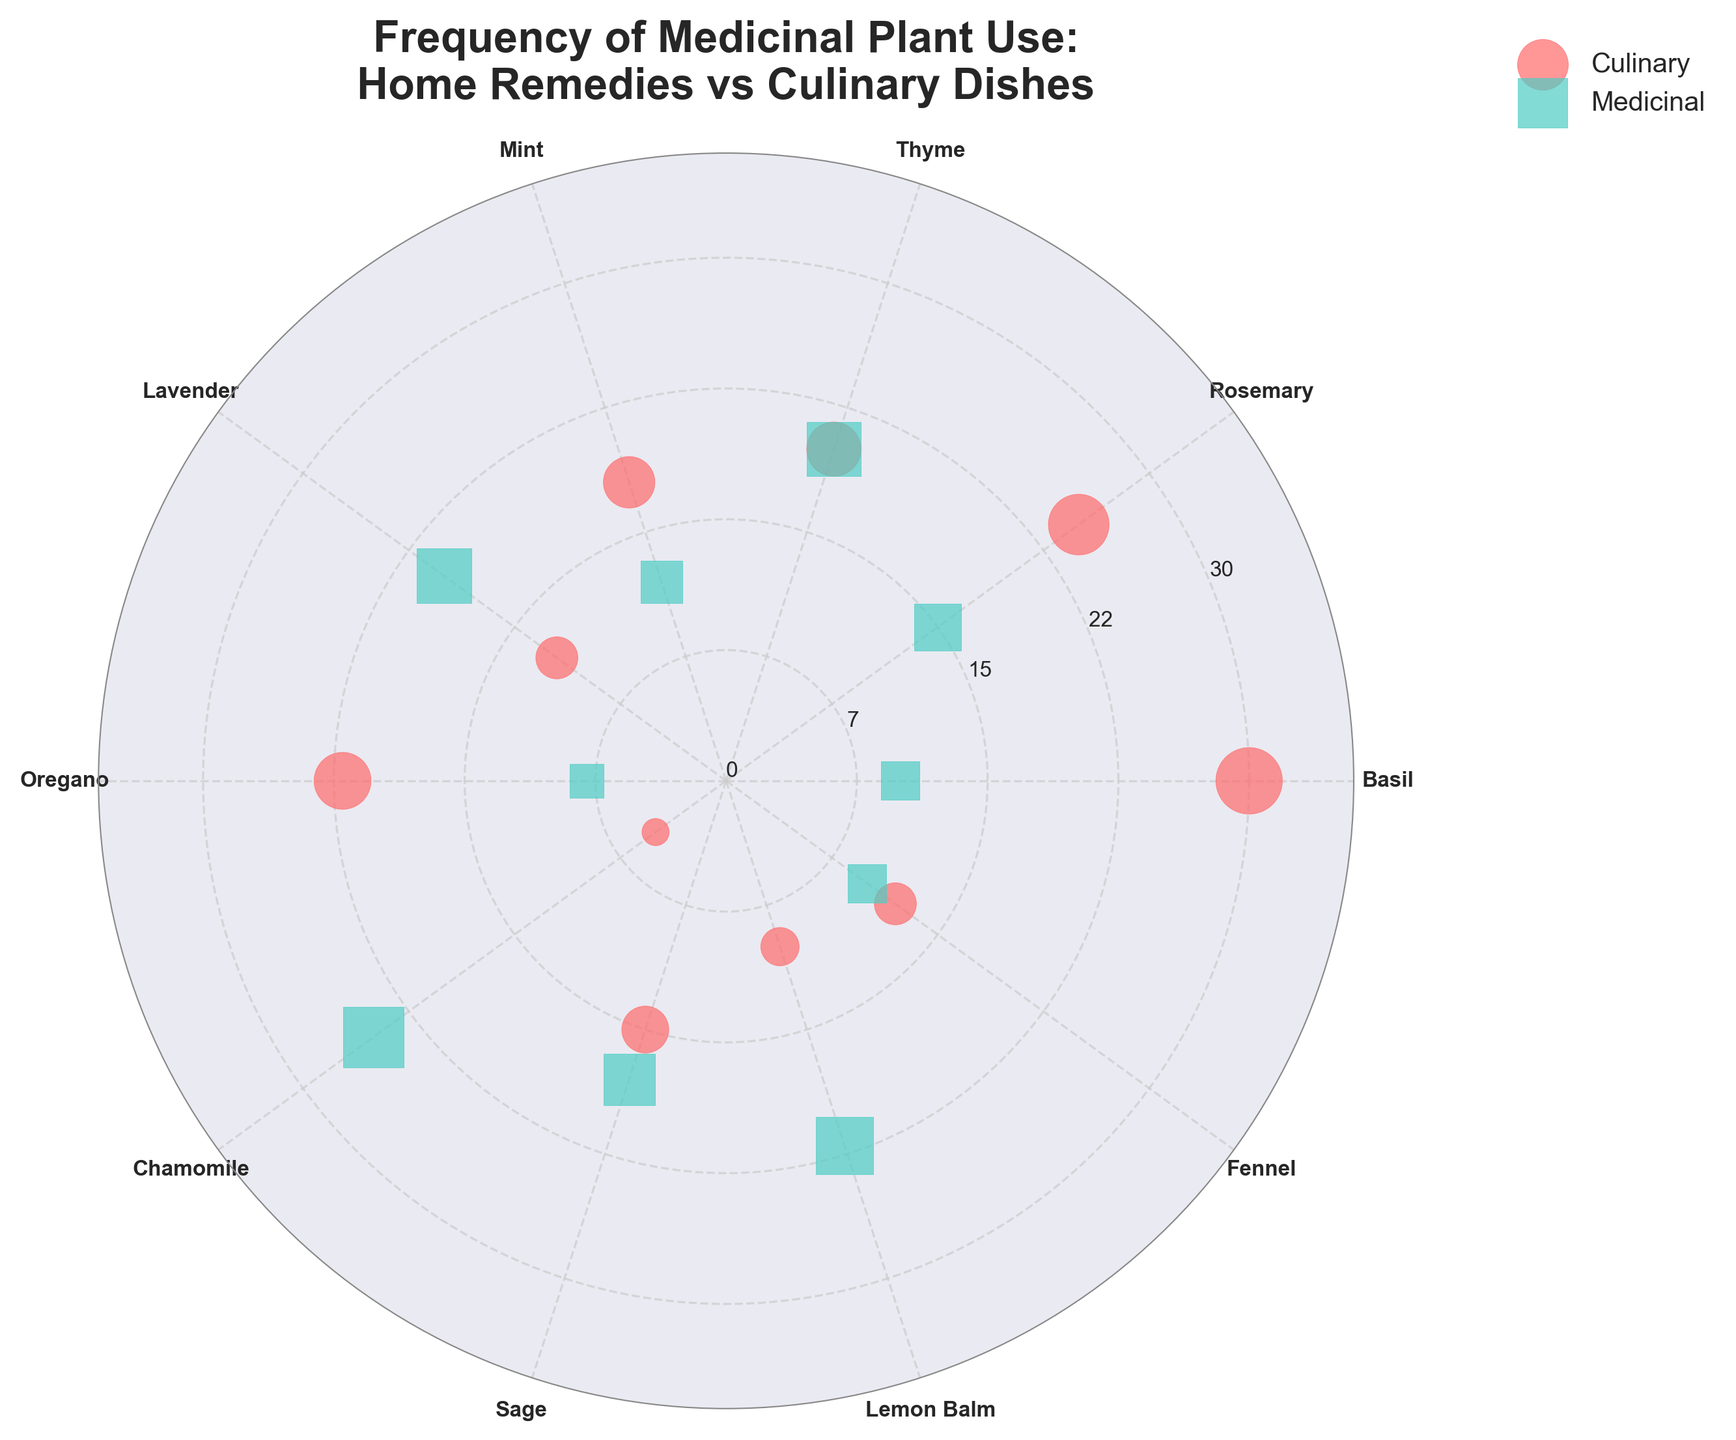What's the title of the chart? The title is prominently displayed at the top of the chart.
Answer: Frequency of Medicinal Plant Use: Home Remedies vs Culinary Dishes Which color represents the culinary category? By referring to the legend on the chart, the color associated with "Culinary" is clear.
Answer: Red How many medicinal plants have higher frequencies in home remedies than in culinary dishes? By comparing the frequencies of the "Medicinal" and "Culinary" categories for each plant, we can count the plants where the medicinal frequency is higher.
Answer: 5 For which plant is the frequency equal in both medicinal and culinary categories? By observing the scatter points, find the plant where the points are at the same radial distance for both categories.
Answer: Thyme Which plant has the highest frequency in culinary dishes? By looking at the culinary category points, identify the one farthest from the center.
Answer: Basil What's the range of frequencies depicted on the radial axis? Observing the radial axis ticks, we can determine the minimum and maximum frequency values.
Answer: 0 to 30 Is there a plant used more frequently in home remedies compared to culinary dishes by more than 10 units? Using the scatter points, check if any medicinal frequency exceeds by 10 units over the culinary frequency for the same plant.
Answer: Yes, Chamomile How many plants are plotted in total? Each unique label around the plot corresponds to a plant. Counting these labels gives the total number of plants.
Answer: 10 Which plant shows the largest discrepancy between its medicinal and culinary use? By visually inspecting the scatter points and calculating the difference in frequencies for each plant, identify the one with the biggest difference.
Answer: Basil 